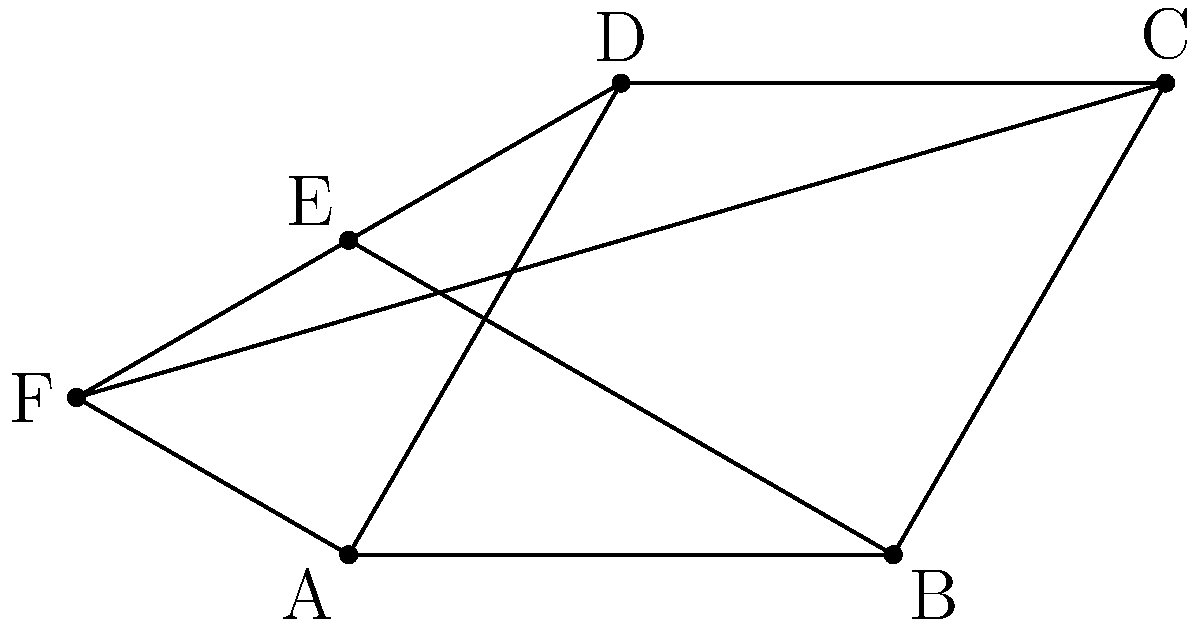While admiring the hexagonal pattern on your vintage jukebox's speaker grille, you notice it forms a perfect regular hexagon. If the distance between opposite vertices of the hexagon is 4 inches, what is the area of the hexagon in square inches? Let's approach this step-by-step:

1) In a regular hexagon, the distance between opposite vertices is equal to twice the length of a side. So if the distance between opposite vertices is 4 inches, the side length is 2 inches.

2) The area of a regular hexagon can be calculated using the formula:

   $$A = \frac{3\sqrt{3}}{2}s^2$$

   Where $s$ is the length of a side.

3) Substituting $s = 2$ into our formula:

   $$A = \frac{3\sqrt{3}}{2}(2^2)$$

4) Simplify:
   $$A = \frac{3\sqrt{3}}{2}(4)$$
   $$A = 6\sqrt{3}$$

5) This can be left as is, or if we want to approximate:
   $$A \approx 10.39 \text{ square inches}$$

Therefore, the area of the hexagon is $6\sqrt{3}$ square inches, or approximately 10.39 square inches.
Answer: $6\sqrt{3}$ square inches 